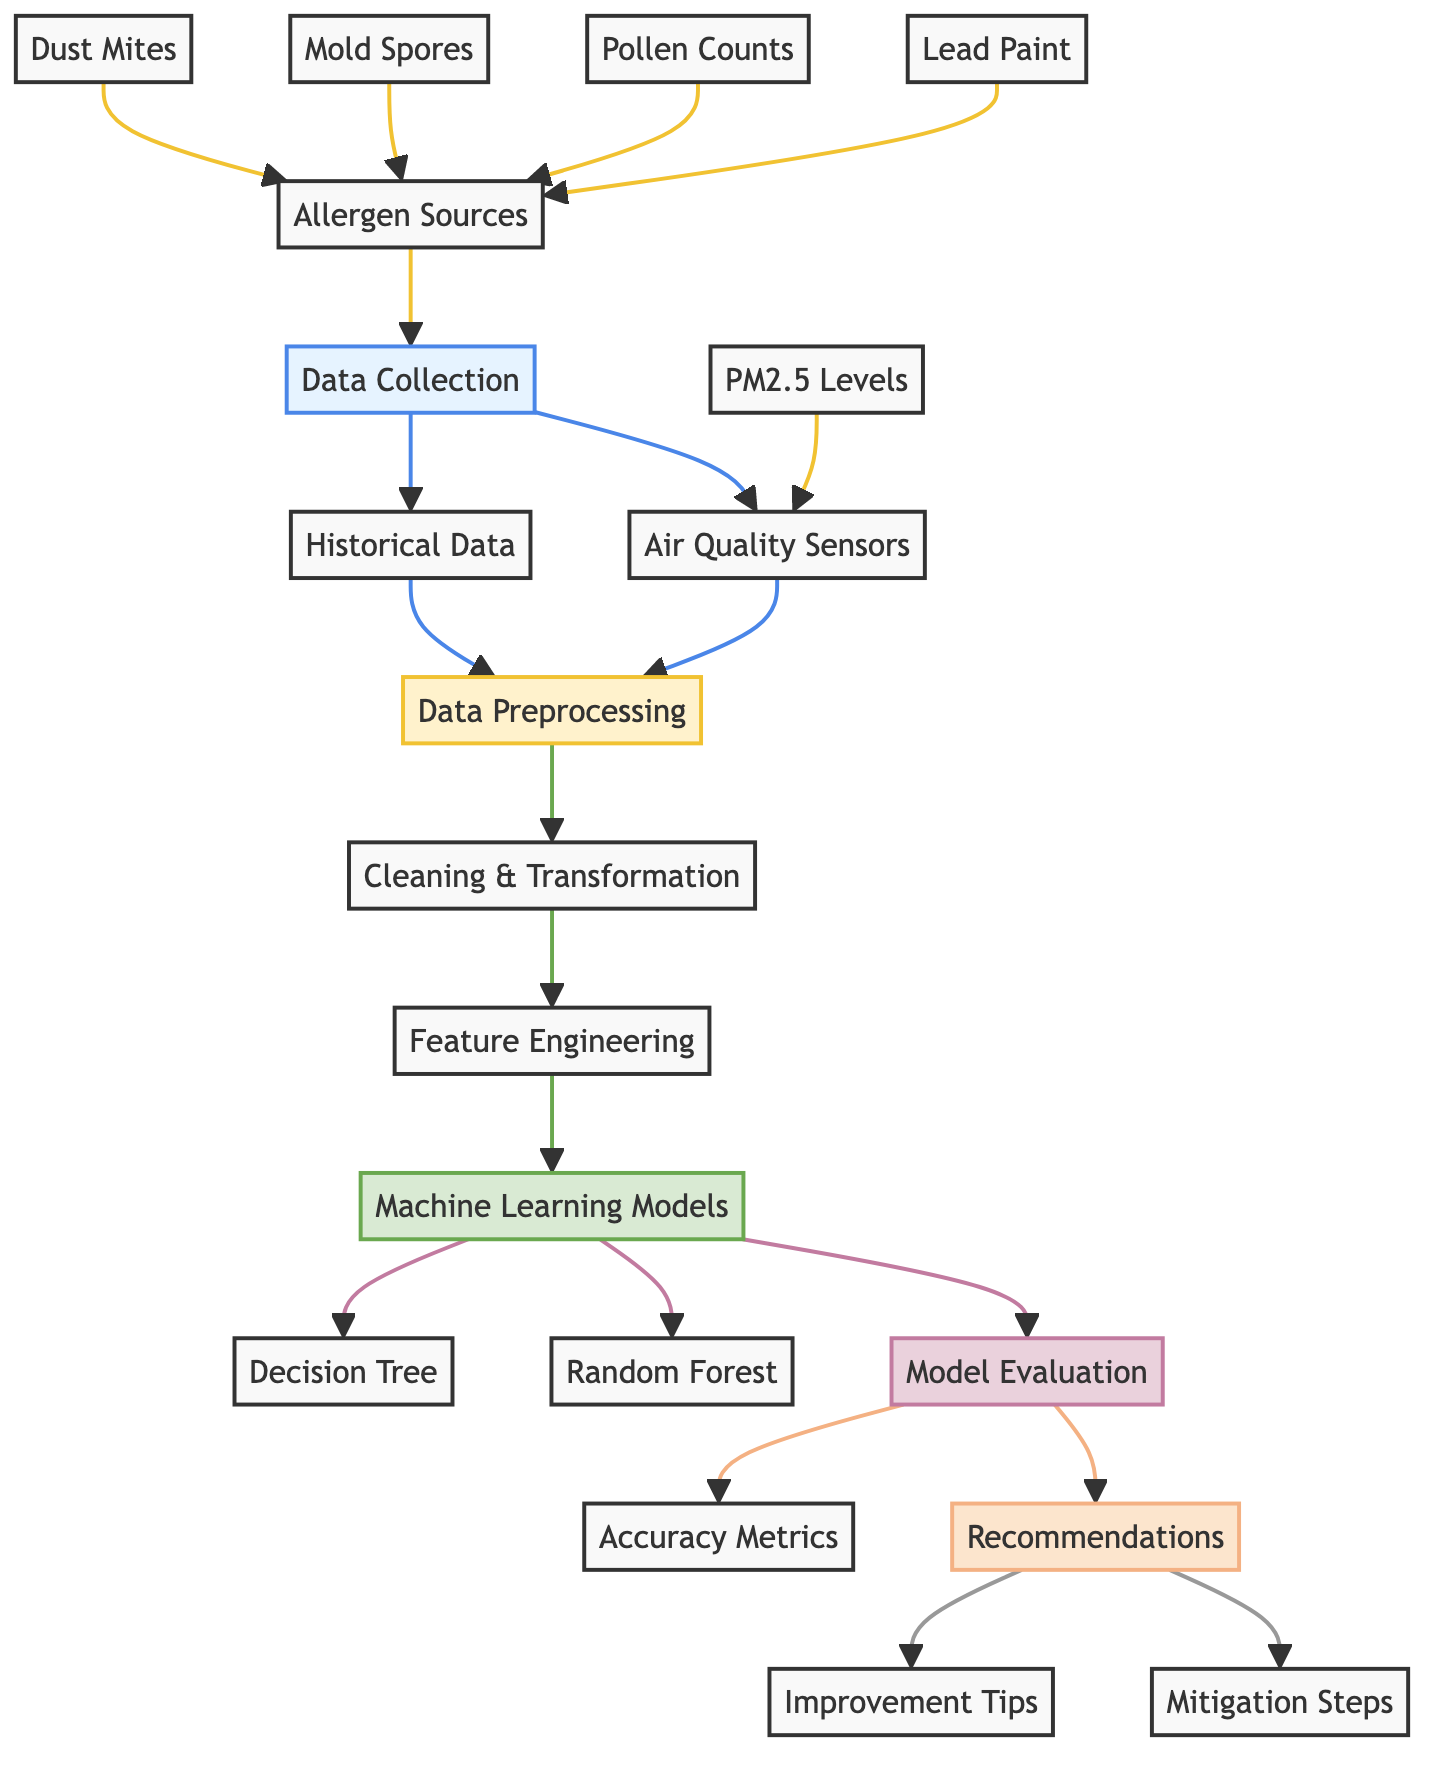What are the sources of allergens identified? The diagram indicates that the sources of allergens are dust mites, mold spores, pollen counts, and lead paint. These nodes connect directly to the allergen sources node.
Answer: Dust mites, mold spores, pollen counts, lead paint How many machine learning models are mentioned in the diagram? The diagram shows two machine learning models: Decision Tree and Random Forest. These models are represented as nodes under the Machine Learning Models section.
Answer: 2 What type of data is collected in the "Data Collection" phase? In the Data Collection phase, historical data and air quality sensors are identified as the types of data collected. These nodes connect to the data collection node.
Answer: Historical data, air quality sensors Which step follows "Data Preprocessing" in the diagram? After the Data Preprocessing step, feature engineering occurs, as shown in the flow of the diagram connecting the Data Preprocessing node to the Feature Engineering node.
Answer: Feature Engineering Which nodes are included in the "Recommendations" phase? The Recommendations phase includes improvement tips and mitigation steps. These two nodes are the outputs of the Model Evaluation node which is indicated in the diagram.
Answer: Improvement tips, mitigation steps What is the primary purpose of "Model Evaluation"? The primary purpose of the Model Evaluation node is to calculate accuracy metrics, which is the only output linked to this node in the diagram.
Answer: Accuracy metrics Which node in the diagram connects allergen sources to dust mites, mold spores, pollen counts, and lead paint? The allergen sources node directly connects to the dust mites, mold spores, pollen counts, and lead paint nodes. This organization shows that these factors contribute to allergen identification.
Answer: Allergen sources What initiates the flow of data in this diagram? The flow of data starts at the Data Collection node, which is the initial point in the diagram connecting to both historical data and air quality sensors.
Answer: Data Collection 